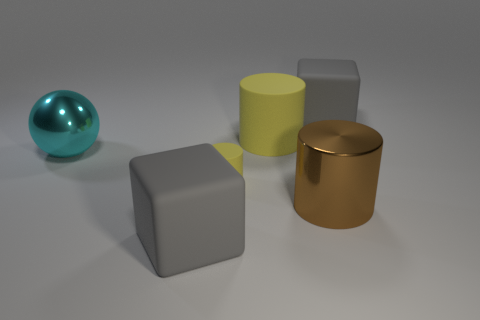What lighting conditions are depicted in the image? The lighting in the image appears to be soft and diffused, with no harsh shadows or bright highlights. It suggests an indoor setting with ambient lighting, perhaps from overhead sources, which evenly illuminates the objects on display. This lighting condition helps accentuate the different material qualities of the objects without causing excessively strong reflections or deep shadows.  What could be the purpose of arranging these objects together? This arrangement of objects could serve multiple purposes. It could be an artistic display meant to showcase contrasts in shape, color, and texture. Alternatively, it might be a scene from a 3D modeling software or a test render used by graphic designers to evaluate material properties and lighting effects in a virtual environment. 